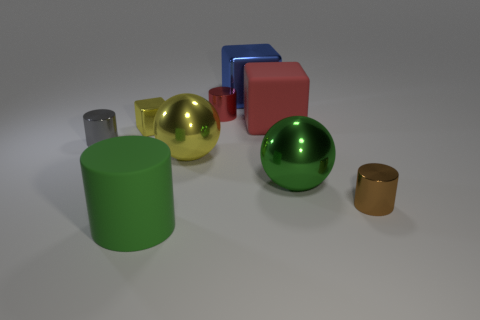Subtract all small red cylinders. How many cylinders are left? 3 Subtract all yellow blocks. How many blocks are left? 2 Subtract 2 cylinders. How many cylinders are left? 2 Subtract all cubes. How many objects are left? 6 Subtract all cyan blocks. How many brown cylinders are left? 1 Subtract all gray blocks. Subtract all gray spheres. How many blocks are left? 3 Subtract all brown rubber cubes. Subtract all small red objects. How many objects are left? 8 Add 7 blue metallic blocks. How many blue metallic blocks are left? 8 Add 5 brown cylinders. How many brown cylinders exist? 6 Subtract 0 cyan cubes. How many objects are left? 9 